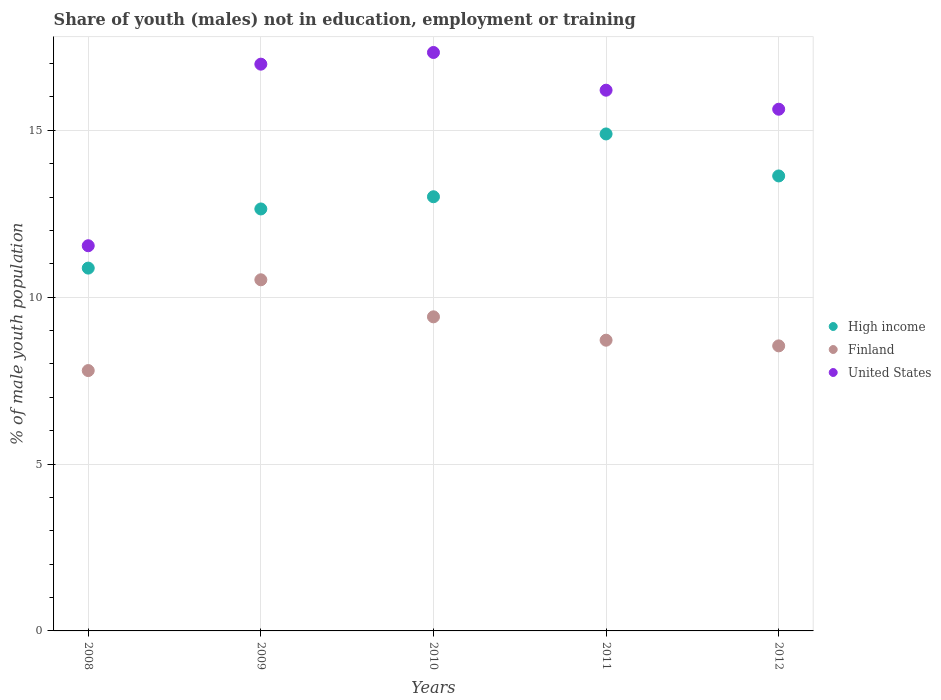How many different coloured dotlines are there?
Your answer should be compact. 3. What is the percentage of unemployed males population in in United States in 2010?
Offer a very short reply. 17.33. Across all years, what is the maximum percentage of unemployed males population in in United States?
Offer a terse response. 17.33. Across all years, what is the minimum percentage of unemployed males population in in Finland?
Offer a terse response. 7.8. In which year was the percentage of unemployed males population in in Finland minimum?
Your response must be concise. 2008. What is the total percentage of unemployed males population in in United States in the graph?
Make the answer very short. 77.68. What is the difference between the percentage of unemployed males population in in Finland in 2008 and that in 2012?
Offer a terse response. -0.74. What is the difference between the percentage of unemployed males population in in High income in 2010 and the percentage of unemployed males population in in United States in 2009?
Offer a very short reply. -3.97. What is the average percentage of unemployed males population in in Finland per year?
Your answer should be compact. 9. In the year 2010, what is the difference between the percentage of unemployed males population in in Finland and percentage of unemployed males population in in High income?
Offer a very short reply. -3.6. What is the ratio of the percentage of unemployed males population in in High income in 2010 to that in 2012?
Your answer should be compact. 0.95. Is the difference between the percentage of unemployed males population in in Finland in 2009 and 2010 greater than the difference between the percentage of unemployed males population in in High income in 2009 and 2010?
Offer a very short reply. Yes. What is the difference between the highest and the second highest percentage of unemployed males population in in United States?
Make the answer very short. 0.35. What is the difference between the highest and the lowest percentage of unemployed males population in in United States?
Your response must be concise. 5.79. What is the title of the graph?
Offer a terse response. Share of youth (males) not in education, employment or training. Does "Oman" appear as one of the legend labels in the graph?
Ensure brevity in your answer.  No. What is the label or title of the Y-axis?
Your response must be concise. % of male youth population. What is the % of male youth population of High income in 2008?
Make the answer very short. 10.87. What is the % of male youth population of Finland in 2008?
Ensure brevity in your answer.  7.8. What is the % of male youth population in United States in 2008?
Your answer should be compact. 11.54. What is the % of male youth population of High income in 2009?
Provide a succinct answer. 12.64. What is the % of male youth population of Finland in 2009?
Keep it short and to the point. 10.52. What is the % of male youth population in United States in 2009?
Ensure brevity in your answer.  16.98. What is the % of male youth population in High income in 2010?
Provide a short and direct response. 13.01. What is the % of male youth population of Finland in 2010?
Make the answer very short. 9.41. What is the % of male youth population in United States in 2010?
Your answer should be compact. 17.33. What is the % of male youth population of High income in 2011?
Give a very brief answer. 14.89. What is the % of male youth population in Finland in 2011?
Offer a very short reply. 8.71. What is the % of male youth population in United States in 2011?
Provide a succinct answer. 16.2. What is the % of male youth population of High income in 2012?
Your answer should be compact. 13.63. What is the % of male youth population in Finland in 2012?
Offer a very short reply. 8.54. What is the % of male youth population in United States in 2012?
Your answer should be compact. 15.63. Across all years, what is the maximum % of male youth population in High income?
Give a very brief answer. 14.89. Across all years, what is the maximum % of male youth population in Finland?
Offer a terse response. 10.52. Across all years, what is the maximum % of male youth population of United States?
Your response must be concise. 17.33. Across all years, what is the minimum % of male youth population of High income?
Ensure brevity in your answer.  10.87. Across all years, what is the minimum % of male youth population of Finland?
Provide a succinct answer. 7.8. Across all years, what is the minimum % of male youth population of United States?
Your answer should be very brief. 11.54. What is the total % of male youth population of High income in the graph?
Give a very brief answer. 65.04. What is the total % of male youth population of Finland in the graph?
Your response must be concise. 44.98. What is the total % of male youth population in United States in the graph?
Offer a very short reply. 77.68. What is the difference between the % of male youth population of High income in 2008 and that in 2009?
Give a very brief answer. -1.77. What is the difference between the % of male youth population in Finland in 2008 and that in 2009?
Your answer should be very brief. -2.72. What is the difference between the % of male youth population in United States in 2008 and that in 2009?
Ensure brevity in your answer.  -5.44. What is the difference between the % of male youth population of High income in 2008 and that in 2010?
Your answer should be very brief. -2.14. What is the difference between the % of male youth population of Finland in 2008 and that in 2010?
Ensure brevity in your answer.  -1.61. What is the difference between the % of male youth population of United States in 2008 and that in 2010?
Your response must be concise. -5.79. What is the difference between the % of male youth population in High income in 2008 and that in 2011?
Provide a short and direct response. -4.02. What is the difference between the % of male youth population of Finland in 2008 and that in 2011?
Your response must be concise. -0.91. What is the difference between the % of male youth population of United States in 2008 and that in 2011?
Your answer should be very brief. -4.66. What is the difference between the % of male youth population in High income in 2008 and that in 2012?
Ensure brevity in your answer.  -2.76. What is the difference between the % of male youth population in Finland in 2008 and that in 2012?
Provide a short and direct response. -0.74. What is the difference between the % of male youth population of United States in 2008 and that in 2012?
Give a very brief answer. -4.09. What is the difference between the % of male youth population of High income in 2009 and that in 2010?
Provide a succinct answer. -0.37. What is the difference between the % of male youth population in Finland in 2009 and that in 2010?
Offer a very short reply. 1.11. What is the difference between the % of male youth population in United States in 2009 and that in 2010?
Keep it short and to the point. -0.35. What is the difference between the % of male youth population in High income in 2009 and that in 2011?
Ensure brevity in your answer.  -2.25. What is the difference between the % of male youth population of Finland in 2009 and that in 2011?
Provide a short and direct response. 1.81. What is the difference between the % of male youth population of United States in 2009 and that in 2011?
Your response must be concise. 0.78. What is the difference between the % of male youth population in High income in 2009 and that in 2012?
Your response must be concise. -0.99. What is the difference between the % of male youth population of Finland in 2009 and that in 2012?
Keep it short and to the point. 1.98. What is the difference between the % of male youth population in United States in 2009 and that in 2012?
Provide a short and direct response. 1.35. What is the difference between the % of male youth population in High income in 2010 and that in 2011?
Your answer should be very brief. -1.88. What is the difference between the % of male youth population in United States in 2010 and that in 2011?
Offer a very short reply. 1.13. What is the difference between the % of male youth population in High income in 2010 and that in 2012?
Offer a terse response. -0.62. What is the difference between the % of male youth population of Finland in 2010 and that in 2012?
Provide a short and direct response. 0.87. What is the difference between the % of male youth population in High income in 2011 and that in 2012?
Ensure brevity in your answer.  1.26. What is the difference between the % of male youth population in Finland in 2011 and that in 2012?
Give a very brief answer. 0.17. What is the difference between the % of male youth population of United States in 2011 and that in 2012?
Ensure brevity in your answer.  0.57. What is the difference between the % of male youth population in High income in 2008 and the % of male youth population in United States in 2009?
Your answer should be compact. -6.11. What is the difference between the % of male youth population of Finland in 2008 and the % of male youth population of United States in 2009?
Make the answer very short. -9.18. What is the difference between the % of male youth population of High income in 2008 and the % of male youth population of Finland in 2010?
Keep it short and to the point. 1.46. What is the difference between the % of male youth population in High income in 2008 and the % of male youth population in United States in 2010?
Your response must be concise. -6.46. What is the difference between the % of male youth population of Finland in 2008 and the % of male youth population of United States in 2010?
Keep it short and to the point. -9.53. What is the difference between the % of male youth population of High income in 2008 and the % of male youth population of Finland in 2011?
Ensure brevity in your answer.  2.16. What is the difference between the % of male youth population of High income in 2008 and the % of male youth population of United States in 2011?
Your response must be concise. -5.33. What is the difference between the % of male youth population in Finland in 2008 and the % of male youth population in United States in 2011?
Give a very brief answer. -8.4. What is the difference between the % of male youth population of High income in 2008 and the % of male youth population of Finland in 2012?
Make the answer very short. 2.33. What is the difference between the % of male youth population of High income in 2008 and the % of male youth population of United States in 2012?
Offer a terse response. -4.76. What is the difference between the % of male youth population in Finland in 2008 and the % of male youth population in United States in 2012?
Ensure brevity in your answer.  -7.83. What is the difference between the % of male youth population in High income in 2009 and the % of male youth population in Finland in 2010?
Make the answer very short. 3.23. What is the difference between the % of male youth population of High income in 2009 and the % of male youth population of United States in 2010?
Your answer should be compact. -4.69. What is the difference between the % of male youth population of Finland in 2009 and the % of male youth population of United States in 2010?
Keep it short and to the point. -6.81. What is the difference between the % of male youth population of High income in 2009 and the % of male youth population of Finland in 2011?
Your response must be concise. 3.93. What is the difference between the % of male youth population in High income in 2009 and the % of male youth population in United States in 2011?
Ensure brevity in your answer.  -3.56. What is the difference between the % of male youth population in Finland in 2009 and the % of male youth population in United States in 2011?
Your answer should be very brief. -5.68. What is the difference between the % of male youth population of High income in 2009 and the % of male youth population of Finland in 2012?
Keep it short and to the point. 4.1. What is the difference between the % of male youth population of High income in 2009 and the % of male youth population of United States in 2012?
Your answer should be compact. -2.99. What is the difference between the % of male youth population of Finland in 2009 and the % of male youth population of United States in 2012?
Give a very brief answer. -5.11. What is the difference between the % of male youth population of High income in 2010 and the % of male youth population of Finland in 2011?
Keep it short and to the point. 4.3. What is the difference between the % of male youth population of High income in 2010 and the % of male youth population of United States in 2011?
Your response must be concise. -3.19. What is the difference between the % of male youth population of Finland in 2010 and the % of male youth population of United States in 2011?
Provide a succinct answer. -6.79. What is the difference between the % of male youth population of High income in 2010 and the % of male youth population of Finland in 2012?
Ensure brevity in your answer.  4.47. What is the difference between the % of male youth population in High income in 2010 and the % of male youth population in United States in 2012?
Ensure brevity in your answer.  -2.62. What is the difference between the % of male youth population in Finland in 2010 and the % of male youth population in United States in 2012?
Provide a short and direct response. -6.22. What is the difference between the % of male youth population of High income in 2011 and the % of male youth population of Finland in 2012?
Ensure brevity in your answer.  6.35. What is the difference between the % of male youth population in High income in 2011 and the % of male youth population in United States in 2012?
Ensure brevity in your answer.  -0.74. What is the difference between the % of male youth population of Finland in 2011 and the % of male youth population of United States in 2012?
Provide a short and direct response. -6.92. What is the average % of male youth population of High income per year?
Keep it short and to the point. 13.01. What is the average % of male youth population of Finland per year?
Make the answer very short. 9. What is the average % of male youth population in United States per year?
Offer a very short reply. 15.54. In the year 2008, what is the difference between the % of male youth population of High income and % of male youth population of Finland?
Your answer should be compact. 3.07. In the year 2008, what is the difference between the % of male youth population of High income and % of male youth population of United States?
Give a very brief answer. -0.67. In the year 2008, what is the difference between the % of male youth population in Finland and % of male youth population in United States?
Provide a short and direct response. -3.74. In the year 2009, what is the difference between the % of male youth population of High income and % of male youth population of Finland?
Provide a succinct answer. 2.12. In the year 2009, what is the difference between the % of male youth population in High income and % of male youth population in United States?
Provide a short and direct response. -4.34. In the year 2009, what is the difference between the % of male youth population in Finland and % of male youth population in United States?
Your response must be concise. -6.46. In the year 2010, what is the difference between the % of male youth population in High income and % of male youth population in Finland?
Your answer should be compact. 3.6. In the year 2010, what is the difference between the % of male youth population in High income and % of male youth population in United States?
Your answer should be very brief. -4.32. In the year 2010, what is the difference between the % of male youth population of Finland and % of male youth population of United States?
Offer a very short reply. -7.92. In the year 2011, what is the difference between the % of male youth population of High income and % of male youth population of Finland?
Give a very brief answer. 6.18. In the year 2011, what is the difference between the % of male youth population of High income and % of male youth population of United States?
Your answer should be compact. -1.31. In the year 2011, what is the difference between the % of male youth population of Finland and % of male youth population of United States?
Offer a terse response. -7.49. In the year 2012, what is the difference between the % of male youth population of High income and % of male youth population of Finland?
Your answer should be very brief. 5.09. In the year 2012, what is the difference between the % of male youth population of High income and % of male youth population of United States?
Ensure brevity in your answer.  -2. In the year 2012, what is the difference between the % of male youth population in Finland and % of male youth population in United States?
Your answer should be very brief. -7.09. What is the ratio of the % of male youth population in High income in 2008 to that in 2009?
Your answer should be very brief. 0.86. What is the ratio of the % of male youth population of Finland in 2008 to that in 2009?
Your response must be concise. 0.74. What is the ratio of the % of male youth population in United States in 2008 to that in 2009?
Keep it short and to the point. 0.68. What is the ratio of the % of male youth population in High income in 2008 to that in 2010?
Ensure brevity in your answer.  0.84. What is the ratio of the % of male youth population in Finland in 2008 to that in 2010?
Offer a terse response. 0.83. What is the ratio of the % of male youth population of United States in 2008 to that in 2010?
Make the answer very short. 0.67. What is the ratio of the % of male youth population of High income in 2008 to that in 2011?
Provide a short and direct response. 0.73. What is the ratio of the % of male youth population of Finland in 2008 to that in 2011?
Ensure brevity in your answer.  0.9. What is the ratio of the % of male youth population of United States in 2008 to that in 2011?
Your answer should be very brief. 0.71. What is the ratio of the % of male youth population of High income in 2008 to that in 2012?
Your answer should be compact. 0.8. What is the ratio of the % of male youth population in Finland in 2008 to that in 2012?
Keep it short and to the point. 0.91. What is the ratio of the % of male youth population in United States in 2008 to that in 2012?
Offer a terse response. 0.74. What is the ratio of the % of male youth population in High income in 2009 to that in 2010?
Make the answer very short. 0.97. What is the ratio of the % of male youth population in Finland in 2009 to that in 2010?
Make the answer very short. 1.12. What is the ratio of the % of male youth population in United States in 2009 to that in 2010?
Offer a terse response. 0.98. What is the ratio of the % of male youth population of High income in 2009 to that in 2011?
Keep it short and to the point. 0.85. What is the ratio of the % of male youth population of Finland in 2009 to that in 2011?
Give a very brief answer. 1.21. What is the ratio of the % of male youth population of United States in 2009 to that in 2011?
Your answer should be compact. 1.05. What is the ratio of the % of male youth population of High income in 2009 to that in 2012?
Make the answer very short. 0.93. What is the ratio of the % of male youth population in Finland in 2009 to that in 2012?
Your answer should be compact. 1.23. What is the ratio of the % of male youth population of United States in 2009 to that in 2012?
Provide a short and direct response. 1.09. What is the ratio of the % of male youth population of High income in 2010 to that in 2011?
Offer a terse response. 0.87. What is the ratio of the % of male youth population of Finland in 2010 to that in 2011?
Make the answer very short. 1.08. What is the ratio of the % of male youth population of United States in 2010 to that in 2011?
Provide a succinct answer. 1.07. What is the ratio of the % of male youth population of High income in 2010 to that in 2012?
Your answer should be very brief. 0.95. What is the ratio of the % of male youth population in Finland in 2010 to that in 2012?
Your answer should be very brief. 1.1. What is the ratio of the % of male youth population in United States in 2010 to that in 2012?
Make the answer very short. 1.11. What is the ratio of the % of male youth population in High income in 2011 to that in 2012?
Keep it short and to the point. 1.09. What is the ratio of the % of male youth population of Finland in 2011 to that in 2012?
Your answer should be compact. 1.02. What is the ratio of the % of male youth population of United States in 2011 to that in 2012?
Offer a terse response. 1.04. What is the difference between the highest and the second highest % of male youth population of High income?
Keep it short and to the point. 1.26. What is the difference between the highest and the second highest % of male youth population in Finland?
Ensure brevity in your answer.  1.11. What is the difference between the highest and the second highest % of male youth population in United States?
Offer a terse response. 0.35. What is the difference between the highest and the lowest % of male youth population in High income?
Keep it short and to the point. 4.02. What is the difference between the highest and the lowest % of male youth population in Finland?
Your response must be concise. 2.72. What is the difference between the highest and the lowest % of male youth population of United States?
Make the answer very short. 5.79. 